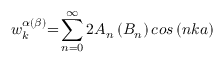<formula> <loc_0><loc_0><loc_500><loc_500>w _ { k } ^ { \alpha \left ( \beta \right ) } { = } \sum _ { n { = 0 } } ^ { \infty } { { 2 } A _ { n } \left ( B _ { n } \right ) { \cos \left ( n k a \right ) \ } }</formula> 